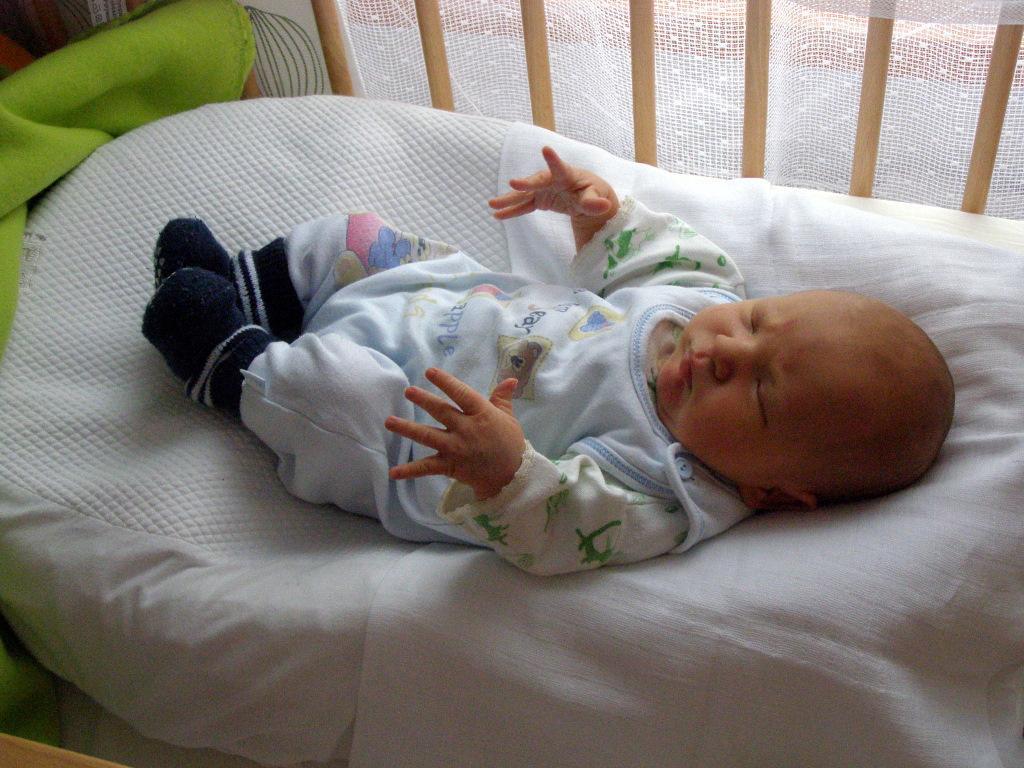In one or two sentences, can you explain what this image depicts? In this picture we can see small baby, sleeping in the cot bed. Behind there is a white color net. 